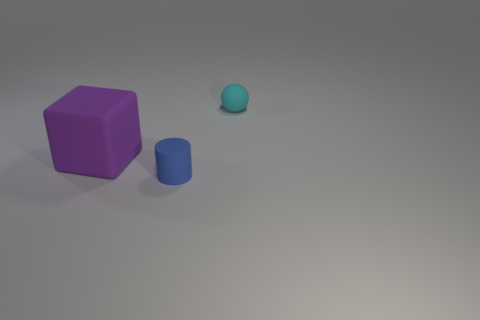Add 2 matte cylinders. How many objects exist? 5 Subtract 1 cubes. How many cubes are left? 0 Subtract all tiny brown metallic cubes. Subtract all big rubber cubes. How many objects are left? 2 Add 3 large purple blocks. How many large purple blocks are left? 4 Add 2 big cyan shiny blocks. How many big cyan shiny blocks exist? 2 Subtract 0 green balls. How many objects are left? 3 Subtract all spheres. How many objects are left? 2 Subtract all purple spheres. Subtract all cyan cylinders. How many spheres are left? 1 Subtract all blue cylinders. How many blue blocks are left? 0 